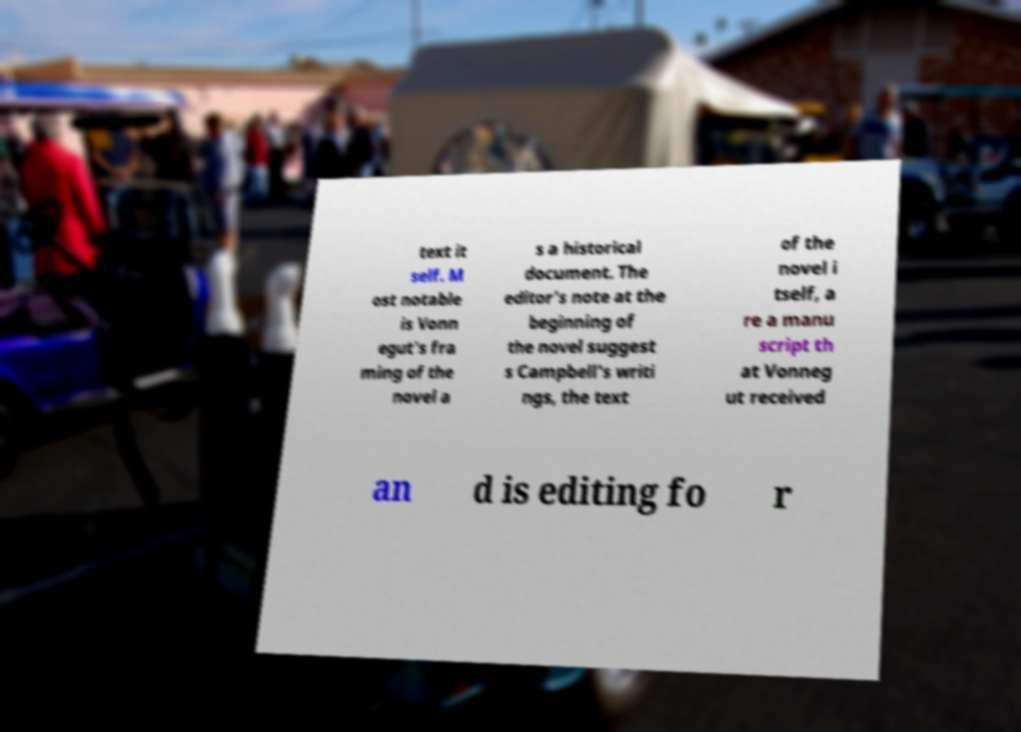Can you accurately transcribe the text from the provided image for me? text it self. M ost notable is Vonn egut's fra ming of the novel a s a historical document. The editor's note at the beginning of the novel suggest s Campbell's writi ngs, the text of the novel i tself, a re a manu script th at Vonneg ut received an d is editing fo r 